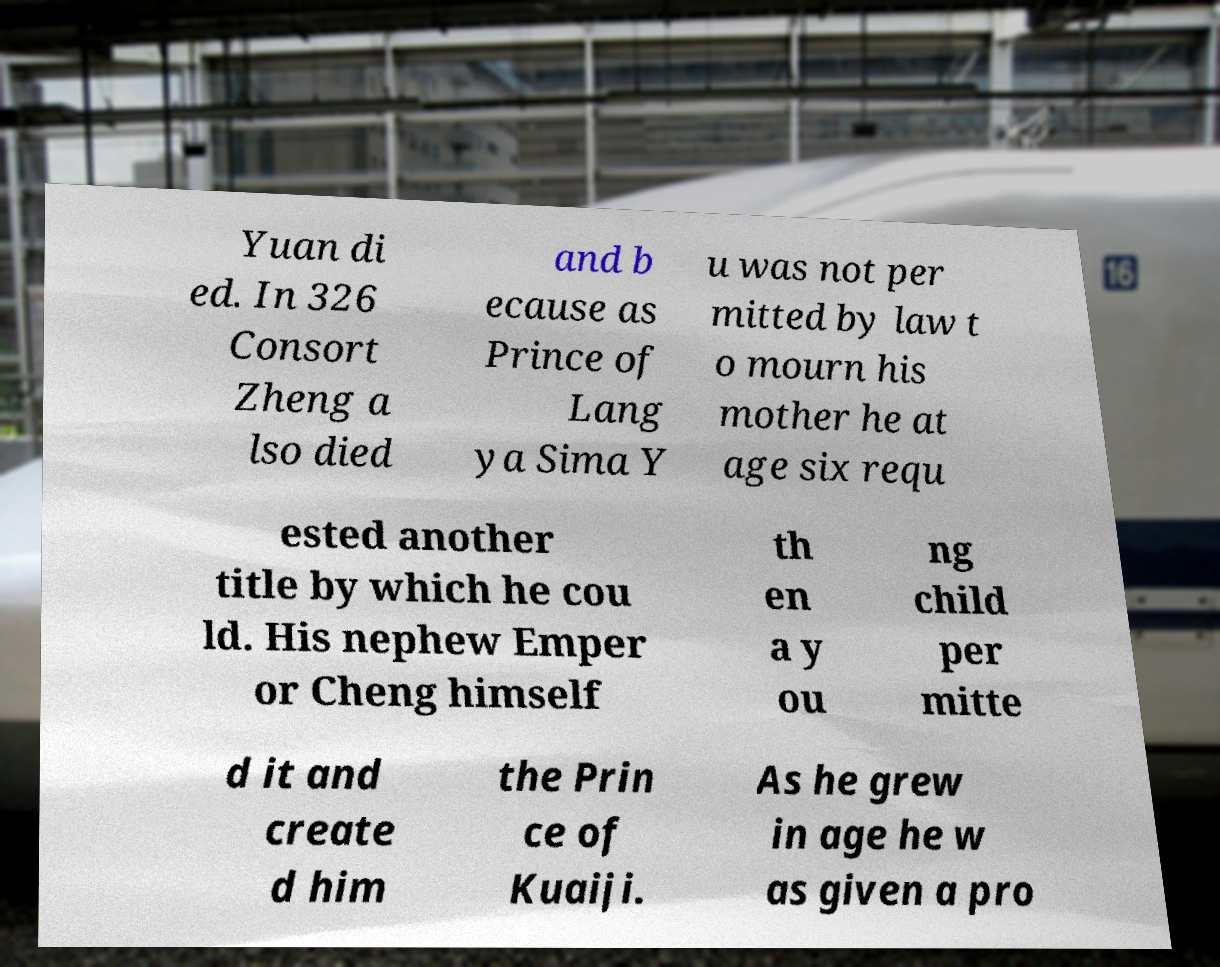Can you read and provide the text displayed in the image?This photo seems to have some interesting text. Can you extract and type it out for me? Yuan di ed. In 326 Consort Zheng a lso died and b ecause as Prince of Lang ya Sima Y u was not per mitted by law t o mourn his mother he at age six requ ested another title by which he cou ld. His nephew Emper or Cheng himself th en a y ou ng child per mitte d it and create d him the Prin ce of Kuaiji. As he grew in age he w as given a pro 